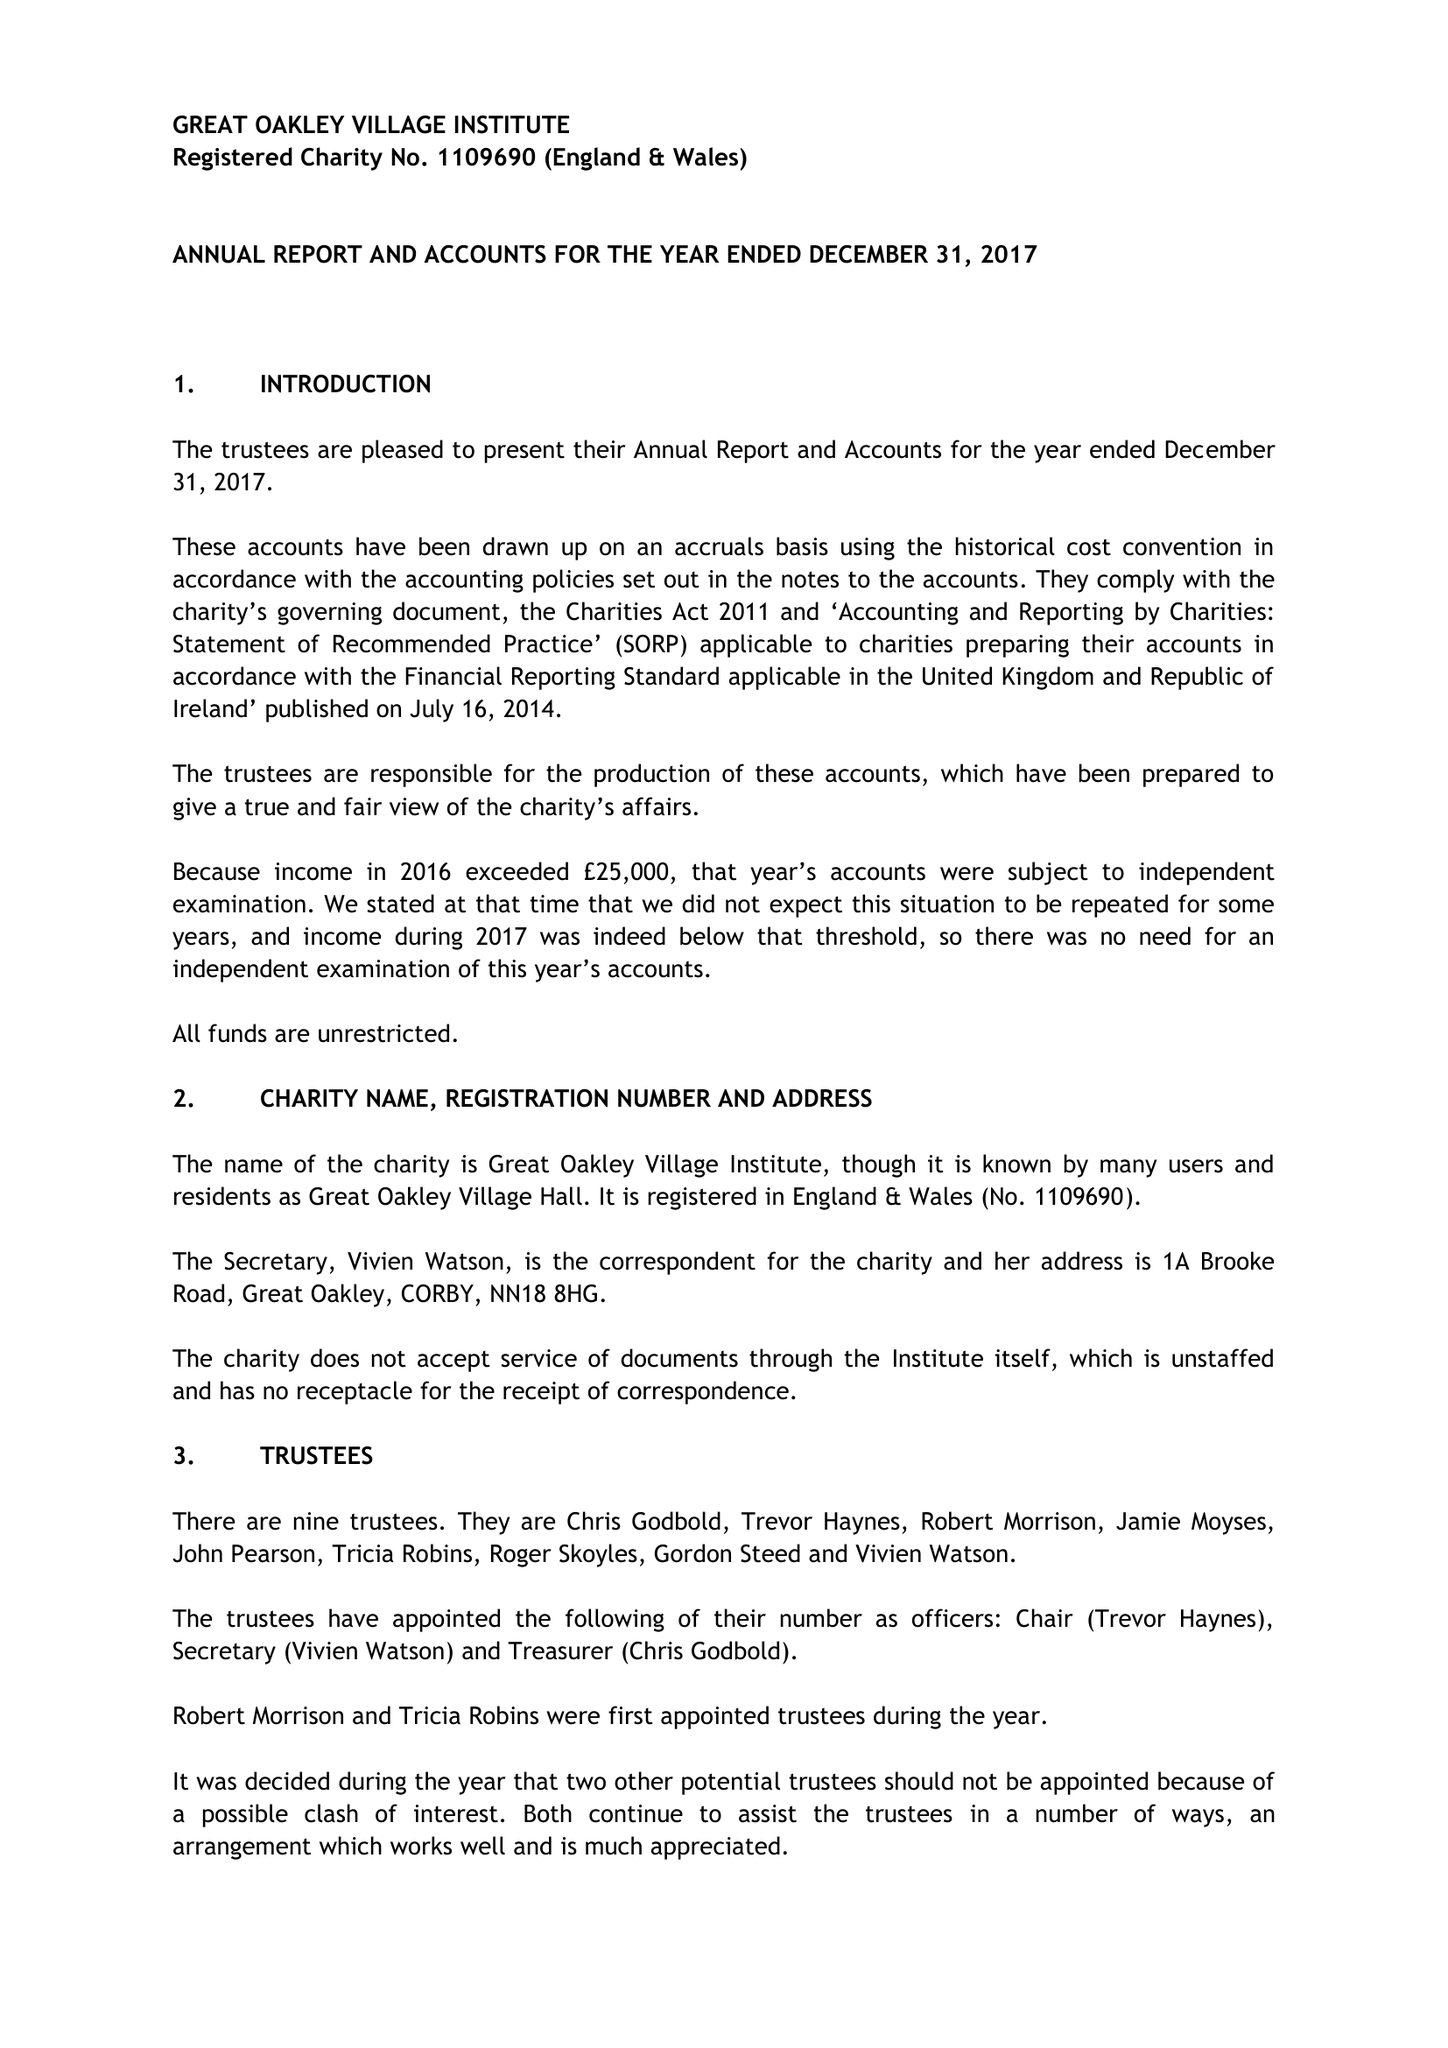What is the value for the report_date?
Answer the question using a single word or phrase. 2016-12-31 